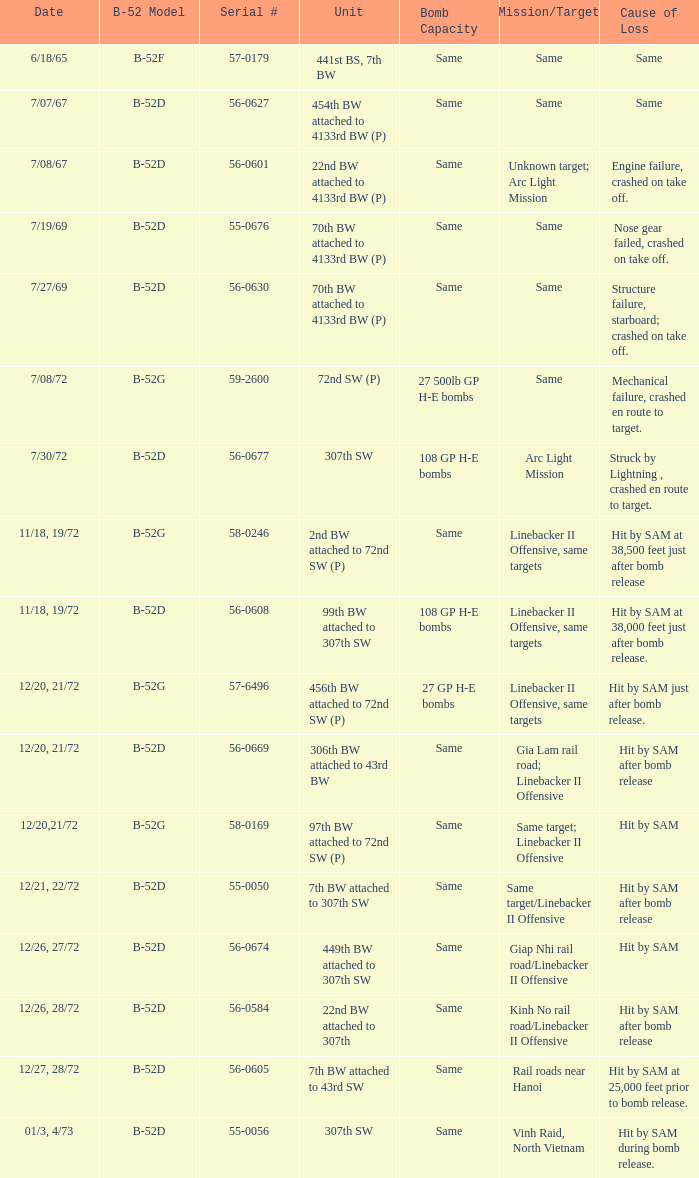When 441st bs, 7th bw is the unit what is the b-52 model? B-52F. 